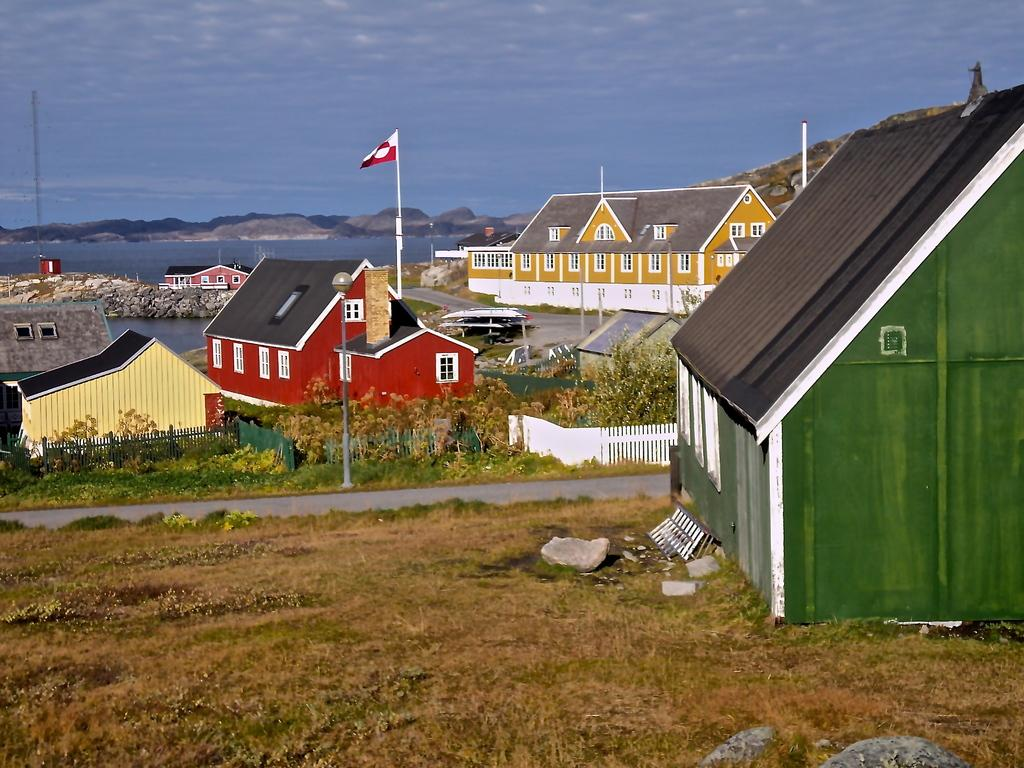What type of vegetation can be seen in the image? There is grass and plants visible in the image. What type of structure is present in the image? There is a fence and houses visible in the image. What is attached to the pole in the image? There is a flag attached to the pole in the image. What natural feature can be seen in the image? There are hills visible in the image. What part of the natural environment is visible in the background of the image? The sky is visible in the background of the image. What type of pet can be seen learning to weave silk in the image? There is no pet or silk weaving activity present in the image. What type of learning material is visible in the image? There is no learning material visible in the image. 